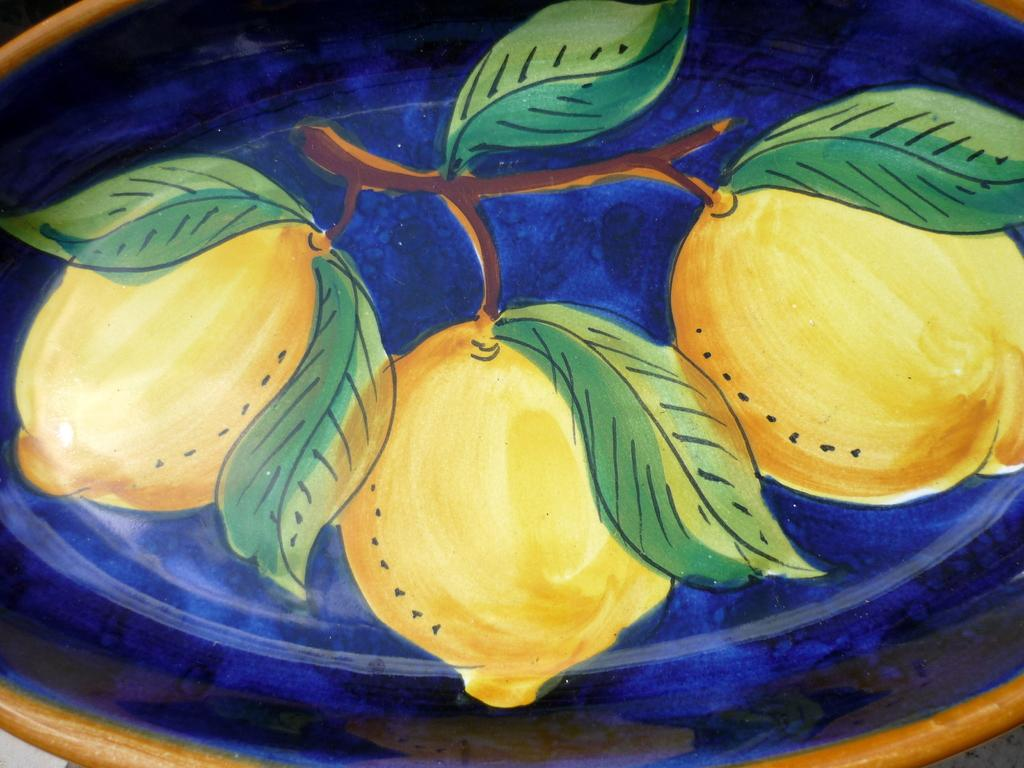What type of objects are depicted in the image? The image contains a depiction of fruits and leaves on a stem. Can you describe the background of the image? The background of the image is blue. What type of amusement can be seen in the image? There is no amusement present in the image; it contains a depiction of fruits and leaves on a stem with a blue background. What kind of beast is visible in the image? There is no beast present in the image; it contains a depiction of fruits and leaves on a stem with a blue background. 